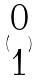Convert formula to latex. <formula><loc_0><loc_0><loc_500><loc_500>( \begin{matrix} 0 \\ 1 \end{matrix} )</formula> 